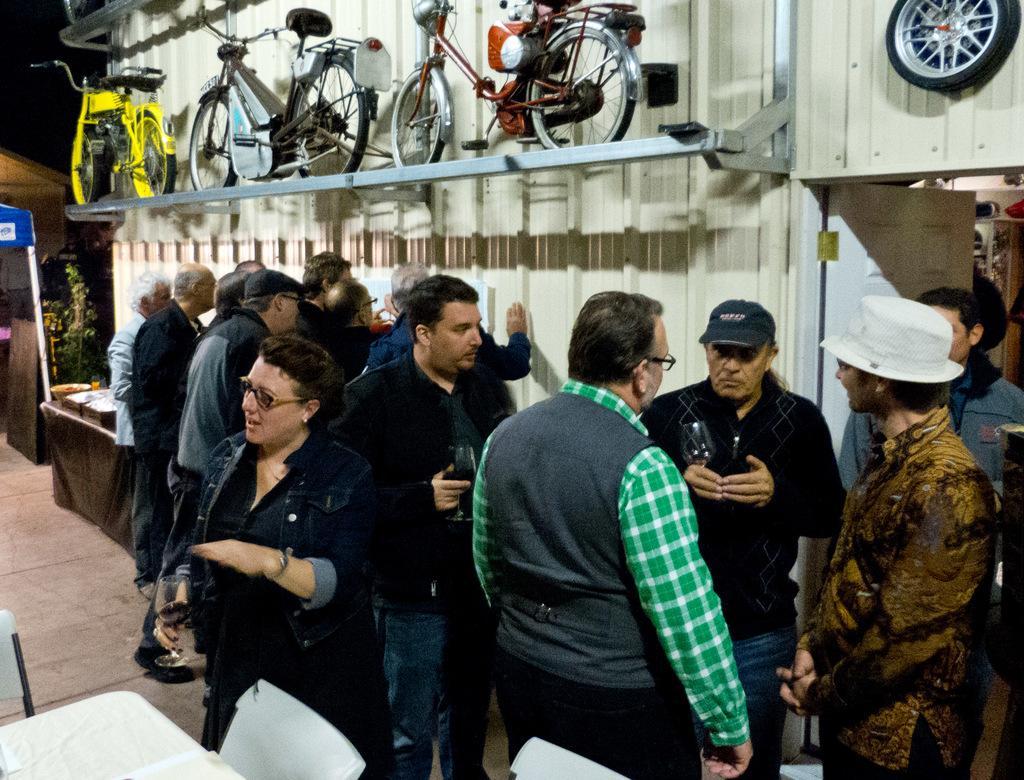Could you give a brief overview of what you see in this image? In this image, we can see some people standing and there are some bicycles. 